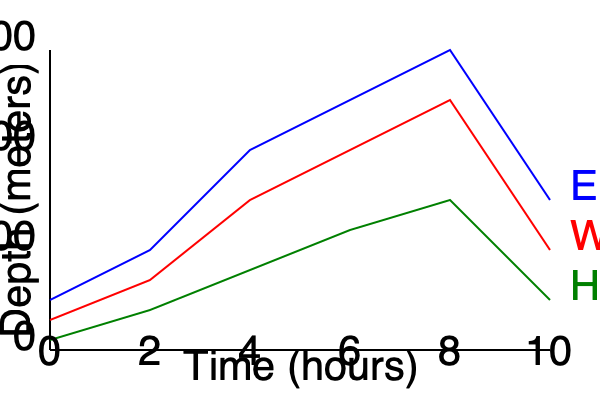Based on the diving depth profiles shown in the graph, which seal species consistently dives the deepest, and what is its maximum depth reached during the 10-hour period? To answer this question, we need to analyze the depth profiles of the three seal species shown in the graph:

1. Identify the species:
   - Blue line: Elephant Seal
   - Red line: Weddell Seal
   - Green line: Harbor Seal

2. Compare the depth profiles:
   - The blue line (Elephant Seal) consistently shows the deepest dives throughout the 10-hour period.
   - The red line (Weddell Seal) shows intermediate depths.
   - The green line (Harbor Seal) remains the shallowest.

3. Determine the maximum depth for the Elephant Seal:
   - The y-axis represents depth in meters, with intervals of 500 meters.
   - The lowest point of the blue line is at the 8-hour mark.
   - This point appears to be slightly above the 1500-meter mark.
   - We can estimate the maximum depth to be approximately 1400 meters.

4. Conclusion:
   The Elephant Seal consistently dives the deepest among the three species, reaching a maximum depth of about 1400 meters during the 10-hour period shown in the graph.
Answer: Elephant Seal; ~1400 meters 